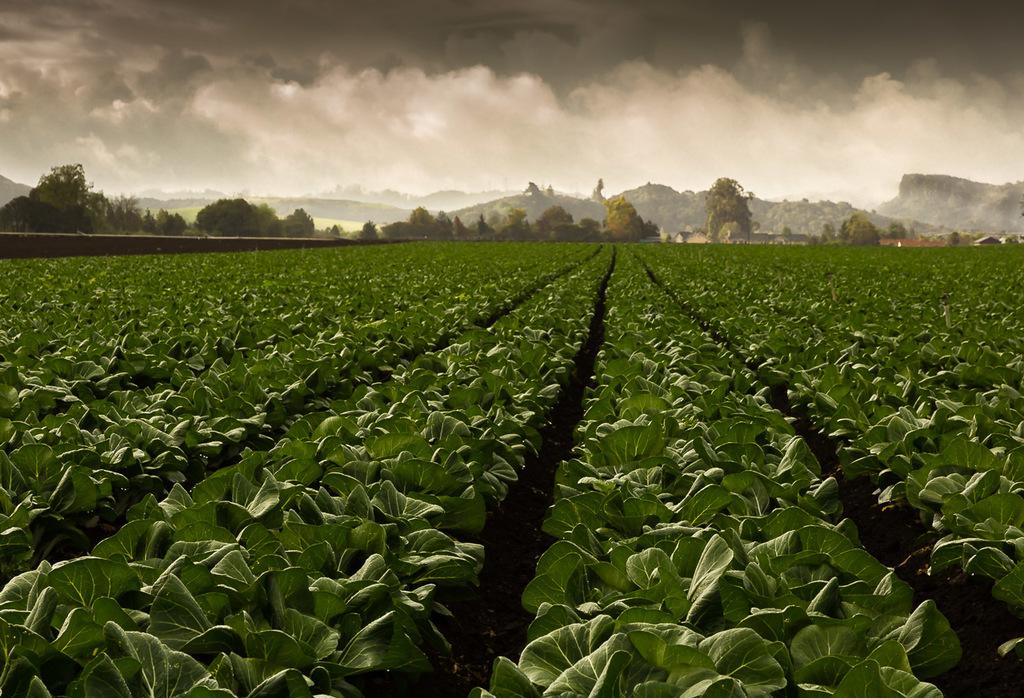What type of plants are visible on the ground in the image? There are plants with green leaves on the ground. What can be seen in the background of the image? There are trees and mountains in the background of the image. What is visible in the sky in the image? There are clouds in the sky. What type of honey can be seen dripping from the trees in the image? There is no honey present in the image; the trees do not have honey dripping from them. 